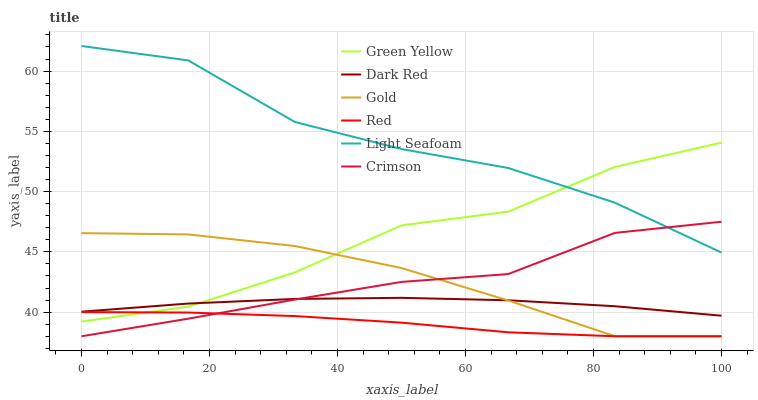Does Red have the minimum area under the curve?
Answer yes or no. Yes. Does Light Seafoam have the maximum area under the curve?
Answer yes or no. Yes. Does Gold have the minimum area under the curve?
Answer yes or no. No. Does Gold have the maximum area under the curve?
Answer yes or no. No. Is Dark Red the smoothest?
Answer yes or no. Yes. Is Light Seafoam the roughest?
Answer yes or no. Yes. Is Gold the smoothest?
Answer yes or no. No. Is Gold the roughest?
Answer yes or no. No. Does Gold have the lowest value?
Answer yes or no. Yes. Does Dark Red have the lowest value?
Answer yes or no. No. Does Light Seafoam have the highest value?
Answer yes or no. Yes. Does Gold have the highest value?
Answer yes or no. No. Is Dark Red less than Light Seafoam?
Answer yes or no. Yes. Is Green Yellow greater than Crimson?
Answer yes or no. Yes. Does Crimson intersect Gold?
Answer yes or no. Yes. Is Crimson less than Gold?
Answer yes or no. No. Is Crimson greater than Gold?
Answer yes or no. No. Does Dark Red intersect Light Seafoam?
Answer yes or no. No. 